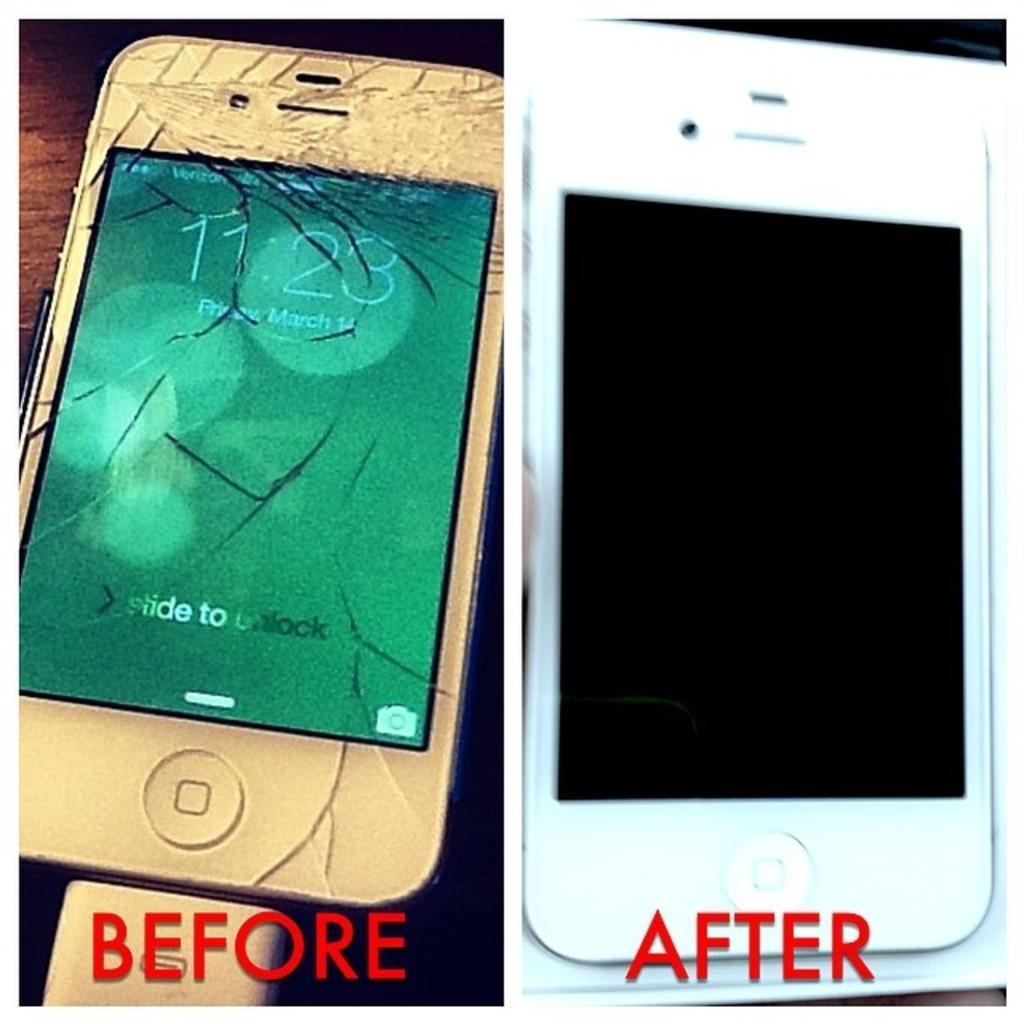In one or two sentences, can you explain what this image depicts? In this image we can see a cracked mobile phone and also the new mobile phone. We can also see the text. 